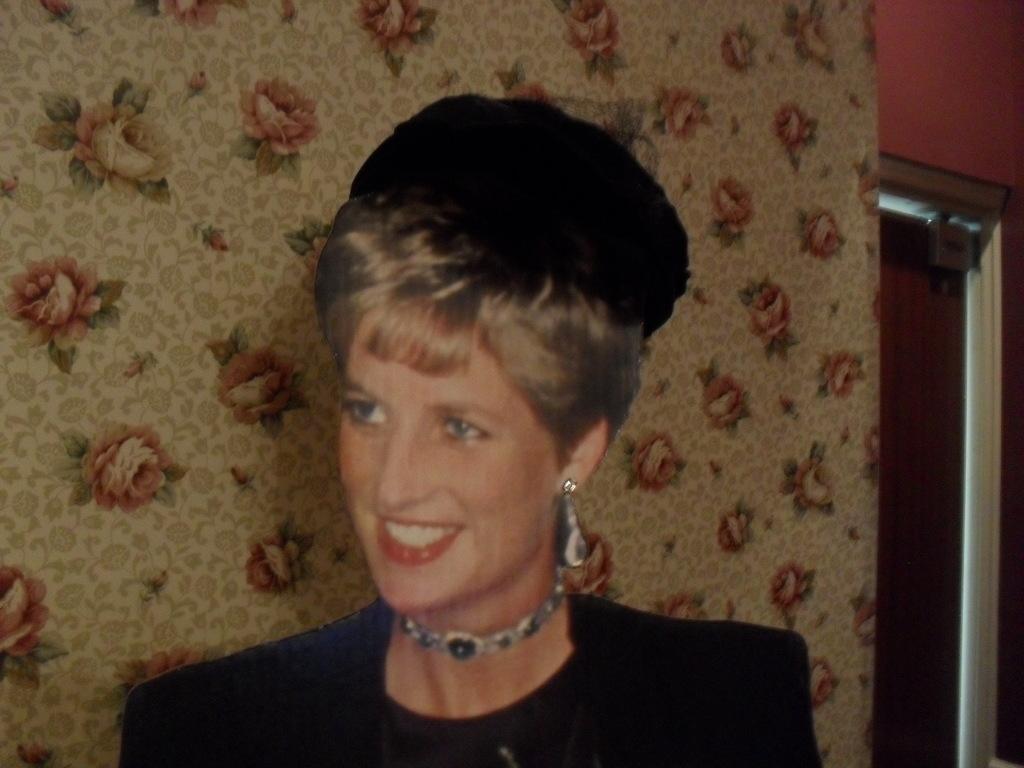How would you summarize this image in a sentence or two? In this picture we can see a woman smiling and she wore some jewelry like ear rings, chain to her neck and in the background we can see curtain flowers design in it. 